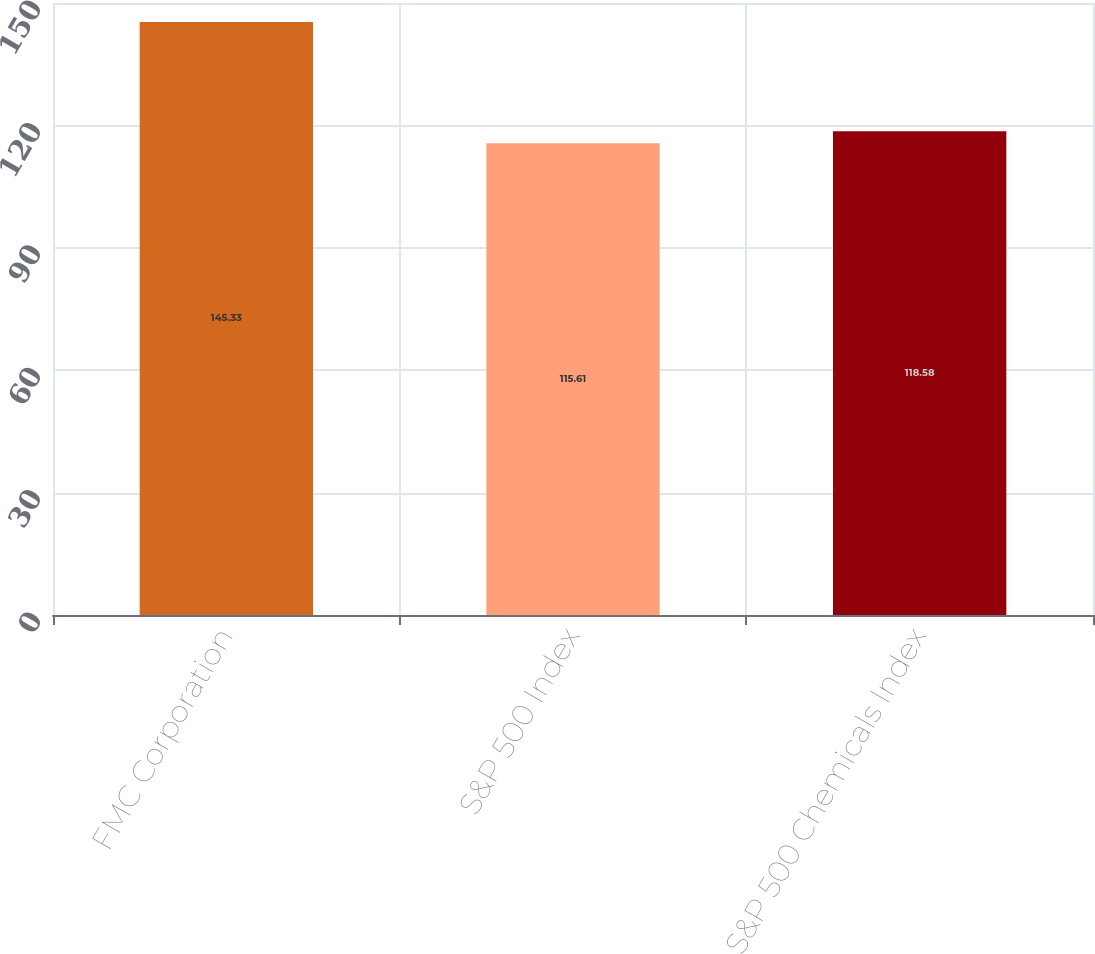<chart> <loc_0><loc_0><loc_500><loc_500><bar_chart><fcel>FMC Corporation<fcel>S&P 500 Index<fcel>S&P 500 Chemicals Index<nl><fcel>145.33<fcel>115.61<fcel>118.58<nl></chart> 